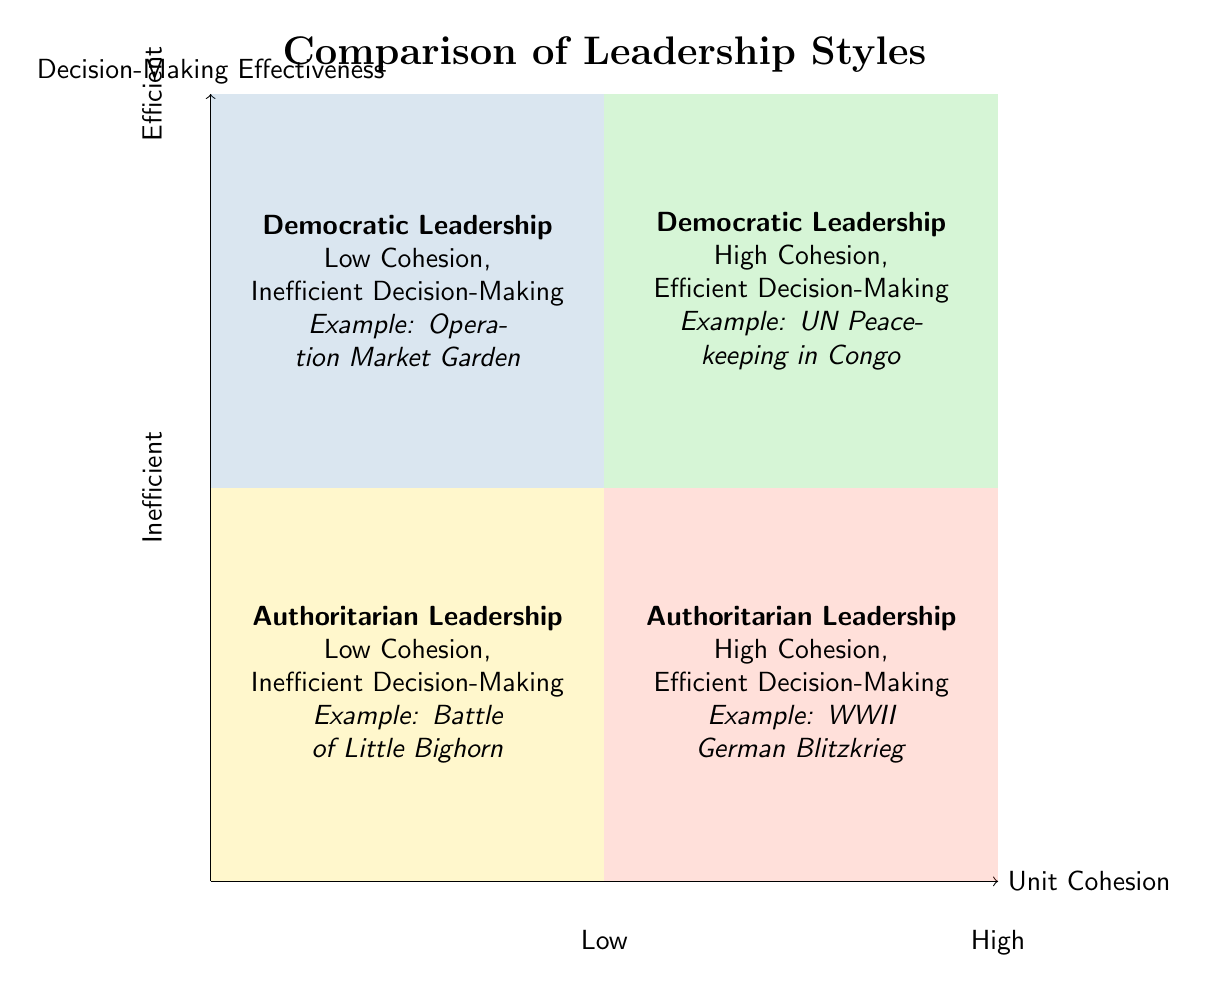What leadership style corresponds to high cohesion and efficient decision-making? The quadrant in the top right displays "Democratic Leadership" along with high cohesion and efficient decision-making, indicating that this combination fits the criteria.
Answer: Democratic Leadership Which example is provided for "Authoritarian Leadership - Low Cohesion, Inefficient Decision-Making"? By looking in the bottom left quadrant, the example "Battle of Little Bighorn" is assigned to this category, showcasing an episode that represents this leadership dynamic.
Answer: Battle of Little Bighorn What is the description for "Democratic Leadership - High Cohesion, Efficient Decision-Making"? The description in the top right quadrant emphasizes that under collaborative leadership, high unit cohesion and effective peacekeeping efforts are achieved, indicating a successful organization.
Answer: Under a collaborative leadership style, high unit cohesion and efficient decision-making can be achieved through shared vision, trust, and adaptive strategies, leading to effective peacekeeping efforts How many quadrants in the chart represent "Authoritarian Leadership"? By counting the quadrants, we find that two of them are labeled with "Authoritarian Leadership" as the common theme, one in the bottom left and one in the bottom right.
Answer: 2 What was the decision-making effectiveness for "Democratic Leadership - Low Cohesion"? Looking at the bottom left quadrant, it indicates "Inefficient Decision-Making", clearly specifying the ineffective aspect of this leadership style within that context.
Answer: Inefficient Decision-Making Which quadrant features "World War II German Blitzkrieg"? The example can be located in the quadrant at the bottom right, associated with the title of "Authoritarian Leadership - High Cohesion, Efficient Decision-Making," which outlines its effectiveness in historical context.
Answer: Authoritarian Leadership - High Cohesion, Efficient Decision-Making What two aspects are compared against leadership styles in this diagram? The axes are labeled "Unit Cohesion" and "Decision-Making Effectiveness", serving as the key metrics to examine the effectiveness of the different leadership styles.
Answer: Unit Cohesion and Decision-Making Effectiveness What does the description of "Democratic Leadership - Low Cohesion, Inefficient Decision-Making" convey? The description indicates a lack of strong leadership can lead to poor cohesion and decision-making, emphasizing the weaknesses associated with this leadership style in historical context.
Answer: Collaboration without strong leadership structure may result in poor unit cohesion and decision-making inefficiency 